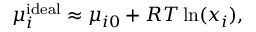<formula> <loc_0><loc_0><loc_500><loc_500>\mu _ { i } ^ { i d e a l } \approx \mu _ { i 0 } + R T \ln ( x _ { i } ) ,</formula> 